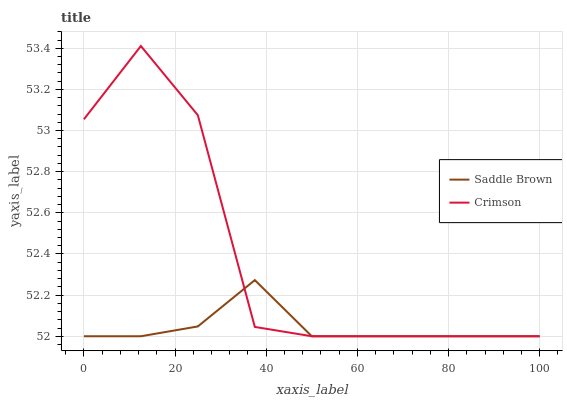Does Saddle Brown have the minimum area under the curve?
Answer yes or no. Yes. Does Crimson have the maximum area under the curve?
Answer yes or no. Yes. Does Saddle Brown have the maximum area under the curve?
Answer yes or no. No. Is Saddle Brown the smoothest?
Answer yes or no. Yes. Is Crimson the roughest?
Answer yes or no. Yes. Is Saddle Brown the roughest?
Answer yes or no. No. Does Crimson have the lowest value?
Answer yes or no. Yes. Does Crimson have the highest value?
Answer yes or no. Yes. Does Saddle Brown have the highest value?
Answer yes or no. No. Does Crimson intersect Saddle Brown?
Answer yes or no. Yes. Is Crimson less than Saddle Brown?
Answer yes or no. No. Is Crimson greater than Saddle Brown?
Answer yes or no. No. 